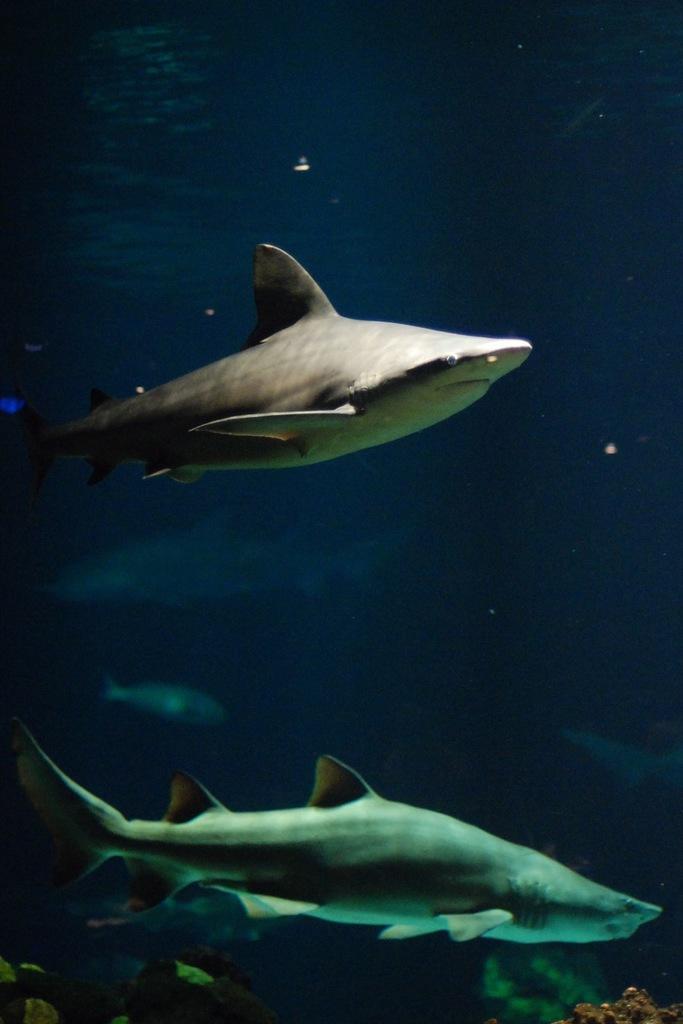How would you summarize this image in a sentence or two? In this image there is a river, in that river there are some fishes and some water plants. 